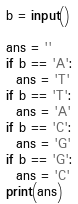<code> <loc_0><loc_0><loc_500><loc_500><_Python_>b = input()

ans = ''
if b == 'A':
  ans = 'T'
if b == 'T':
  ans = 'A'
if b == 'C':
  ans = 'G'
if b == 'G':
  ans = 'C'
print(ans)</code> 